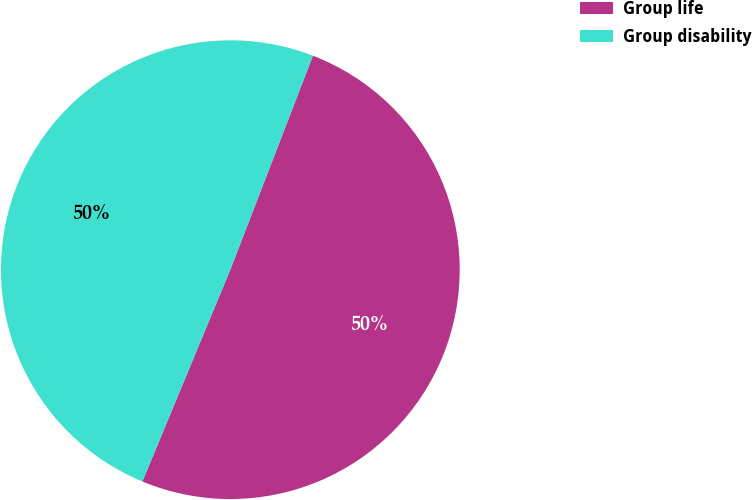<chart> <loc_0><loc_0><loc_500><loc_500><pie_chart><fcel>Group life<fcel>Group disability<nl><fcel>50.4%<fcel>49.6%<nl></chart> 